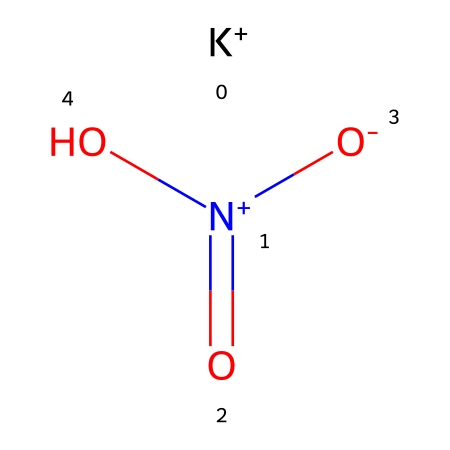What is the molecular formula of this compound? By analyzing the SMILES representation, we can identify the elements and the number of atoms present. In total, there is one potassium (K), one nitrogen (N), and three oxygen (O) atoms, which gives us the molecular formula of KNO3.
Answer: KNO3 How many oxygen atoms are present in this structure? The SMILES representation indicates there are three oxygen atoms depicted in the formula: two are double-bonded to nitrogen, and one is single-bonded to nitrogen. This can be counted directly from the structure.
Answer: three What type of chemical bond connects the nitrogen and the oxygen atoms? In the provided structure, nitrogen forms one double bond with two of the oxygen atoms and a single bond with the third oxygen atom. This indicates that the nitrogen-oxygen connections involve both double and single covalent bonding.
Answer: covalent What is the charge on the potassium ion in this compound? The SMILES representation shows that potassium is represented as K+, indicating that it has a positive charge of +1. This is typical for alkali metal ions.
Answer: +1 Is potassium nitrate an acid or a base? Potassium nitrate lacks hydrogen ions that would characterize it as an acid, and it does not have hydroxide ions associated with bases. Therefore, it is classified as a neutral salt.
Answer: neutral salt What is the primary use of potassium nitrate historically? Traditionally, potassium nitrate has been widely utilized in gunpowder production due to its oxidizing properties. This trait aids in the combustion process essential for explosive reactions.
Answer: gunpowder 